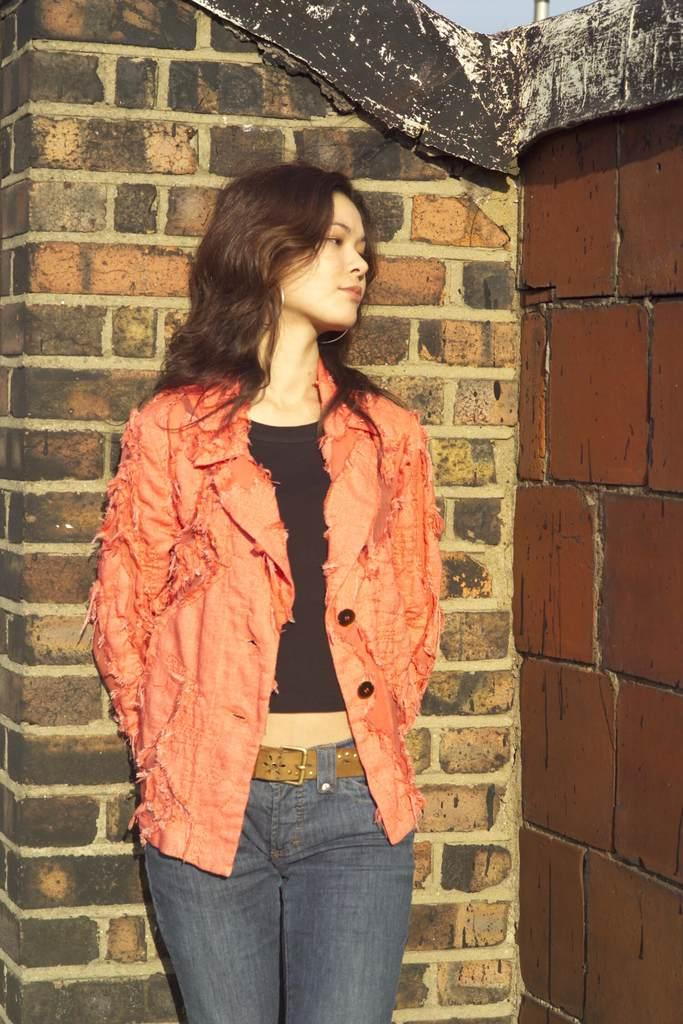Who is present in the image? There is a woman in the image. What is the woman doing in the image? The woman is standing. What type of clothing is the woman wearing? The woman is wearing a jacket and blue jeans. What can be seen in the background of the image? There is a brick wall in the background of the image. What type of wren can be seen perched on the woman's shoulder in the image? There is no wren present in the image; it only features a woman standing in front of a brick wall. 